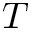<formula> <loc_0><loc_0><loc_500><loc_500>T</formula> 